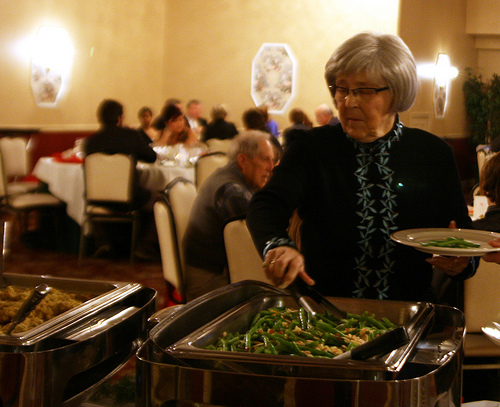<image>
Can you confirm if the food is under the plate? Yes. The food is positioned underneath the plate, with the plate above it in the vertical space. 